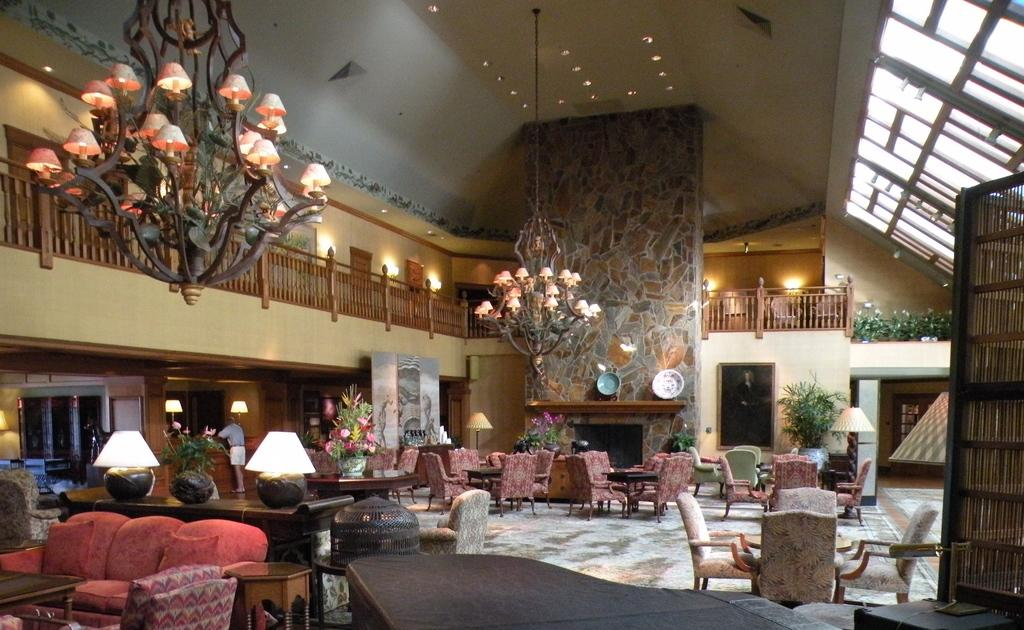What is hanging from the ceiling in the room? There is a chandelier hanging in the room. What type of barrier is present near the first floor? There is a fence with lights near the first floor. Can you describe the man's position in the room? A man is standing in one corner of the room. What type of furniture is present in the room? There are many chairs and tables in the room. How does the moon affect the lighting in the room? The image does not show the moon or any indication of its effect on the lighting in the room. What type of eggnog is being served in the room? There is no mention of eggnog or any food or beverage in the image. 